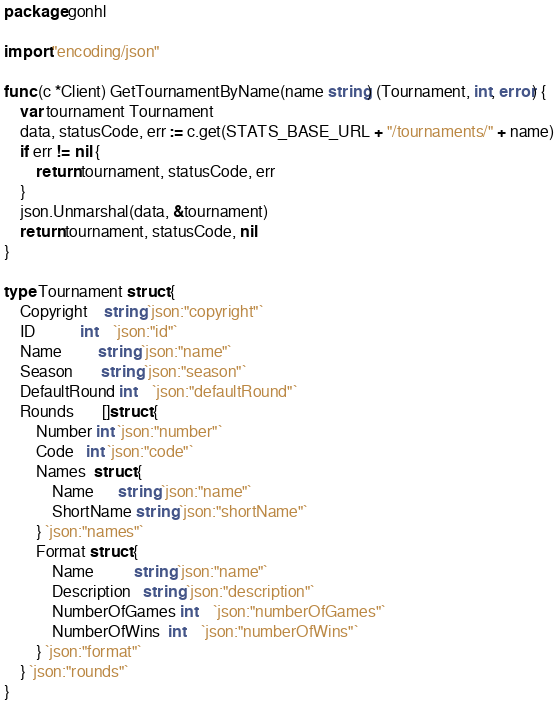<code> <loc_0><loc_0><loc_500><loc_500><_Go_>package gonhl

import "encoding/json"

func (c *Client) GetTournamentByName(name string) (Tournament, int, error) {
	var tournament Tournament
	data, statusCode, err := c.get(STATS_BASE_URL + "/tournaments/" + name)
	if err != nil {
		return tournament, statusCode, err
	}
	json.Unmarshal(data, &tournament)
	return tournament, statusCode, nil
}

type Tournament struct {
	Copyright    string `json:"copyright"`
	ID           int    `json:"id"`
	Name         string `json:"name"`
	Season       string `json:"season"`
	DefaultRound int    `json:"defaultRound"`
	Rounds       []struct {
		Number int `json:"number"`
		Code   int `json:"code"`
		Names  struct {
			Name      string `json:"name"`
			ShortName string `json:"shortName"`
		} `json:"names"`
		Format struct {
			Name          string `json:"name"`
			Description   string `json:"description"`
			NumberOfGames int    `json:"numberOfGames"`
			NumberOfWins  int    `json:"numberOfWins"`
		} `json:"format"`
	} `json:"rounds"`
}
</code> 